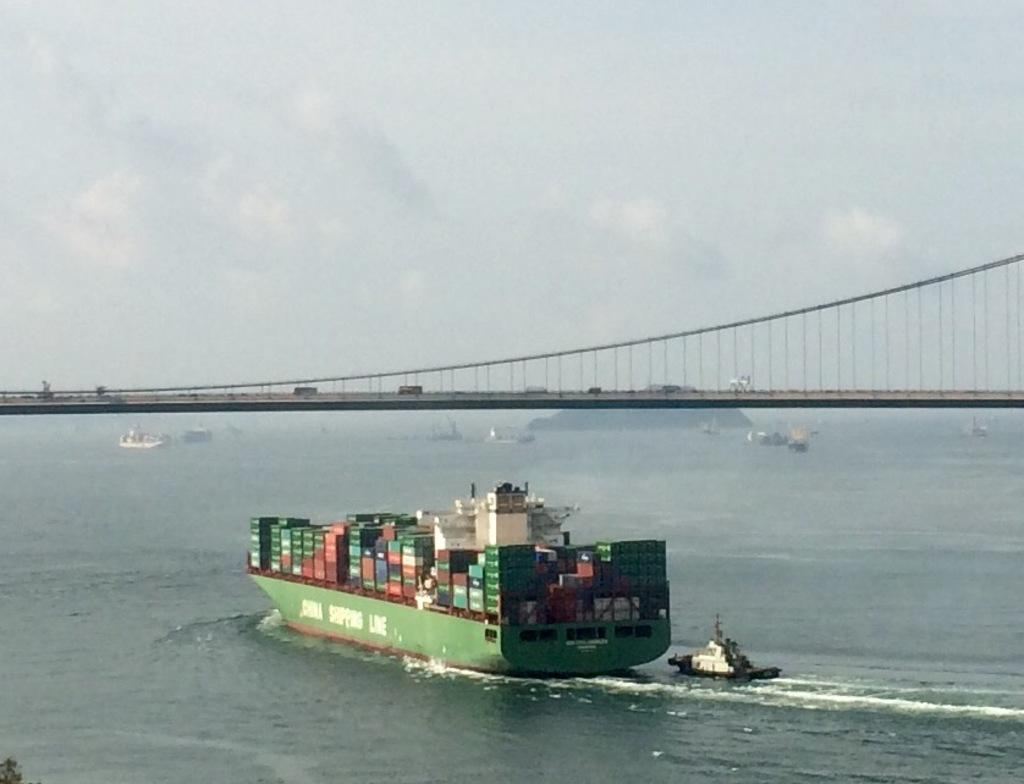What type of body of water is present in the image? There is an ocean in the image. What is floating on the ocean? There are boats in the ocean. What structure can be seen in the image? There is a bridge in the image. What feature does the bridge have? The bridge has a fence. What is visible at the top of the image? The sky is visible at the top of the image. What can be found on the ship in the image? There are boxes on the ship. What type of loaf can be seen floating in the ocean in the image? There is no loaf present in the image; it features an ocean with boats and a bridge. How many toes are visible on the bridge in the image? There are no toes visible in the image; it features a bridge with a fence. 